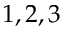<formula> <loc_0><loc_0><loc_500><loc_500>1 , 2 , 3</formula> 